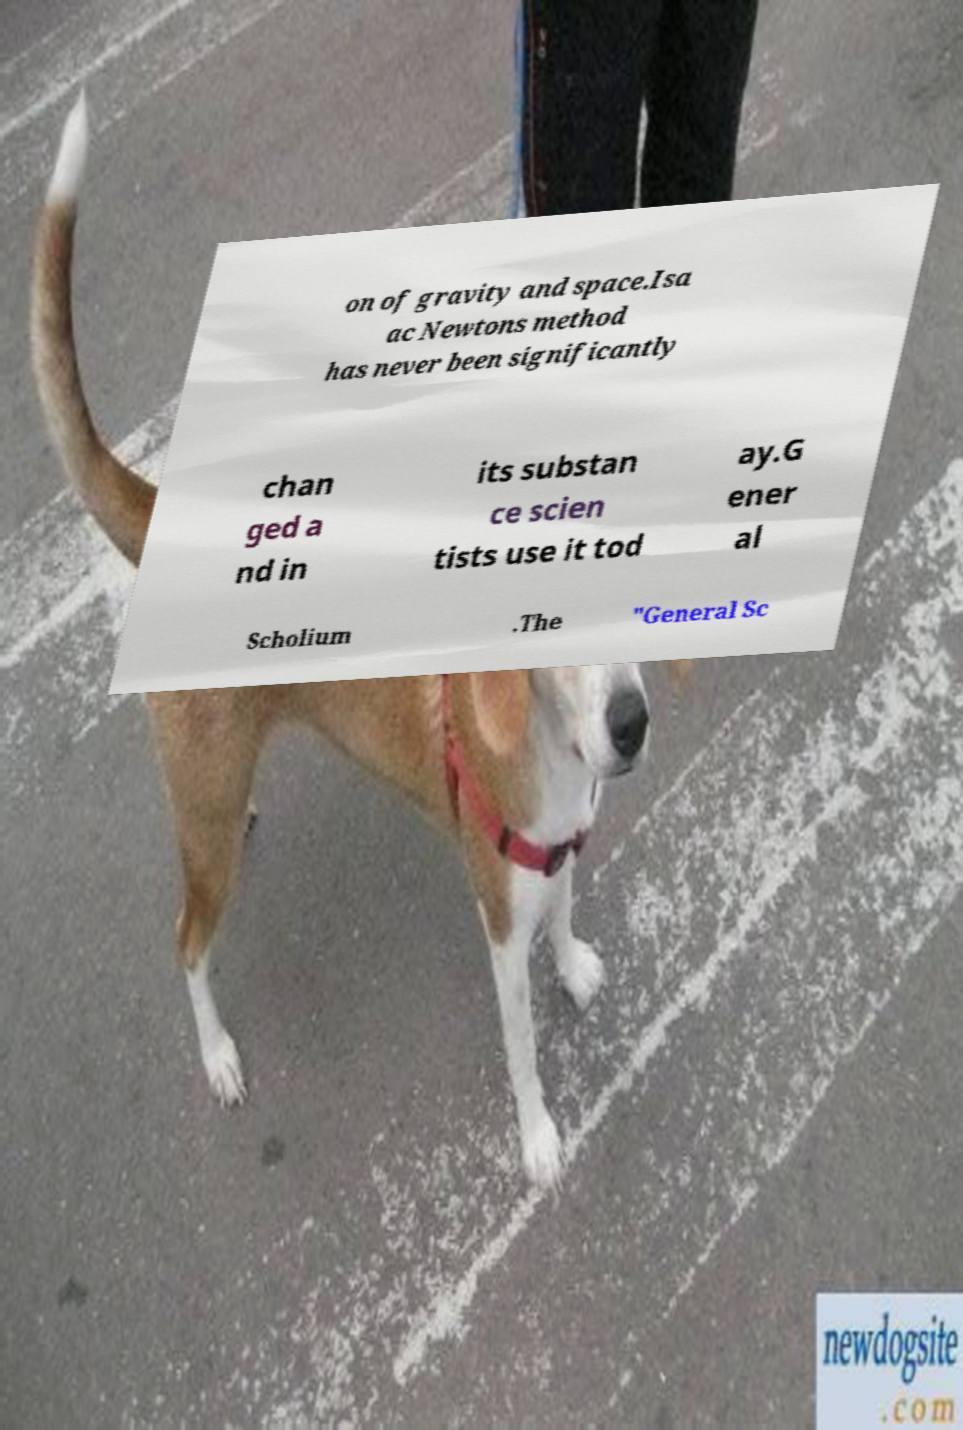Can you accurately transcribe the text from the provided image for me? on of gravity and space.Isa ac Newtons method has never been significantly chan ged a nd in its substan ce scien tists use it tod ay.G ener al Scholium .The "General Sc 